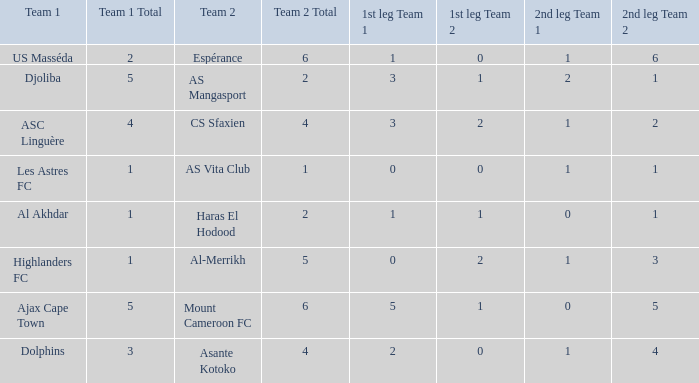What is the 2nd leg of team 1 Dolphins? 1–4 1. 